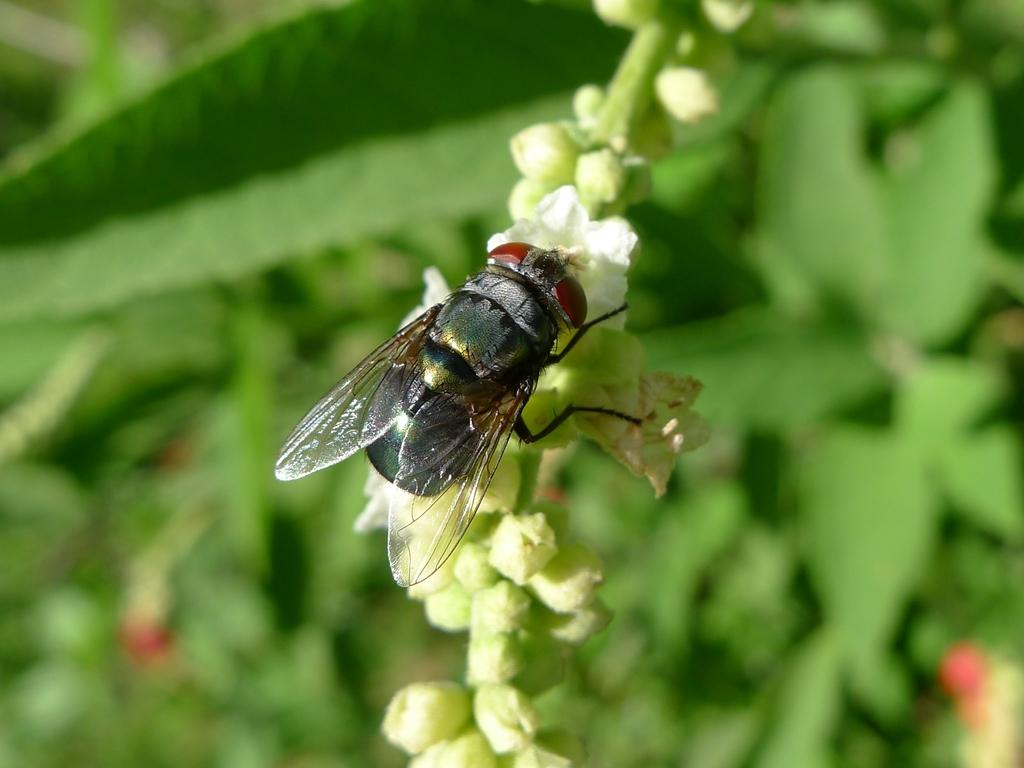What insect is present on the flower in the image? There is a housefly on a white flower in the image. What can be seen in the background of the image? There are plants in the background of the image. How would you describe the background of the image? The background is blurred. What type of apparel is the housefly wearing in the image? Houseflies do not wear apparel, so this question cannot be answered. 